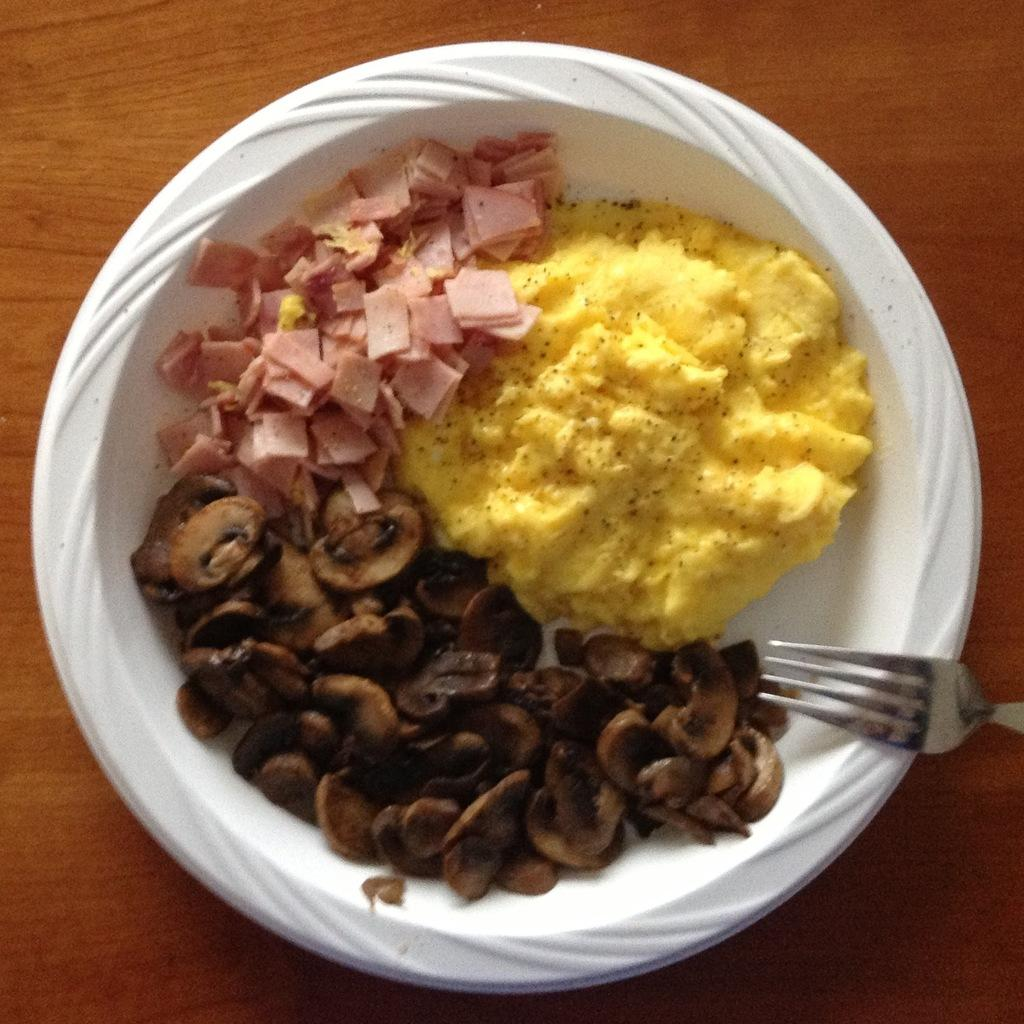What is on the plate in the image? There is a food item on a plate in the image. What utensil can be seen on the table in the image? There is a fork on the table in the image. What piece of furniture is present in the image? The table is present in the image. What type of crack can be heard in the image? There is no cracking sound present in the image. 